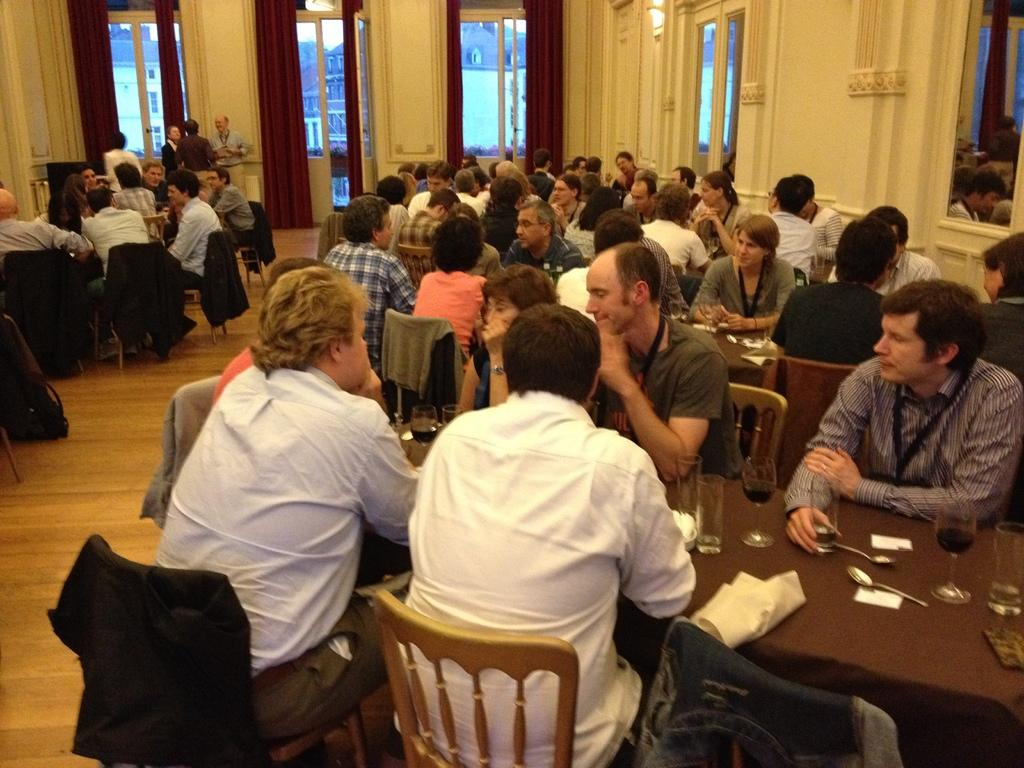How many people are in the image? There is a group of people in the image. What are the people doing in the image? The people are seated on chairs. Where are the chairs located? The chairs are in a room. What furniture can be seen in the room besides the chairs? There is at least one table in the room. What type of clouds can be seen through the window in the image? There is no window or clouds visible in the image. What sound does the horn make in the image? There is no horn present in the image. 